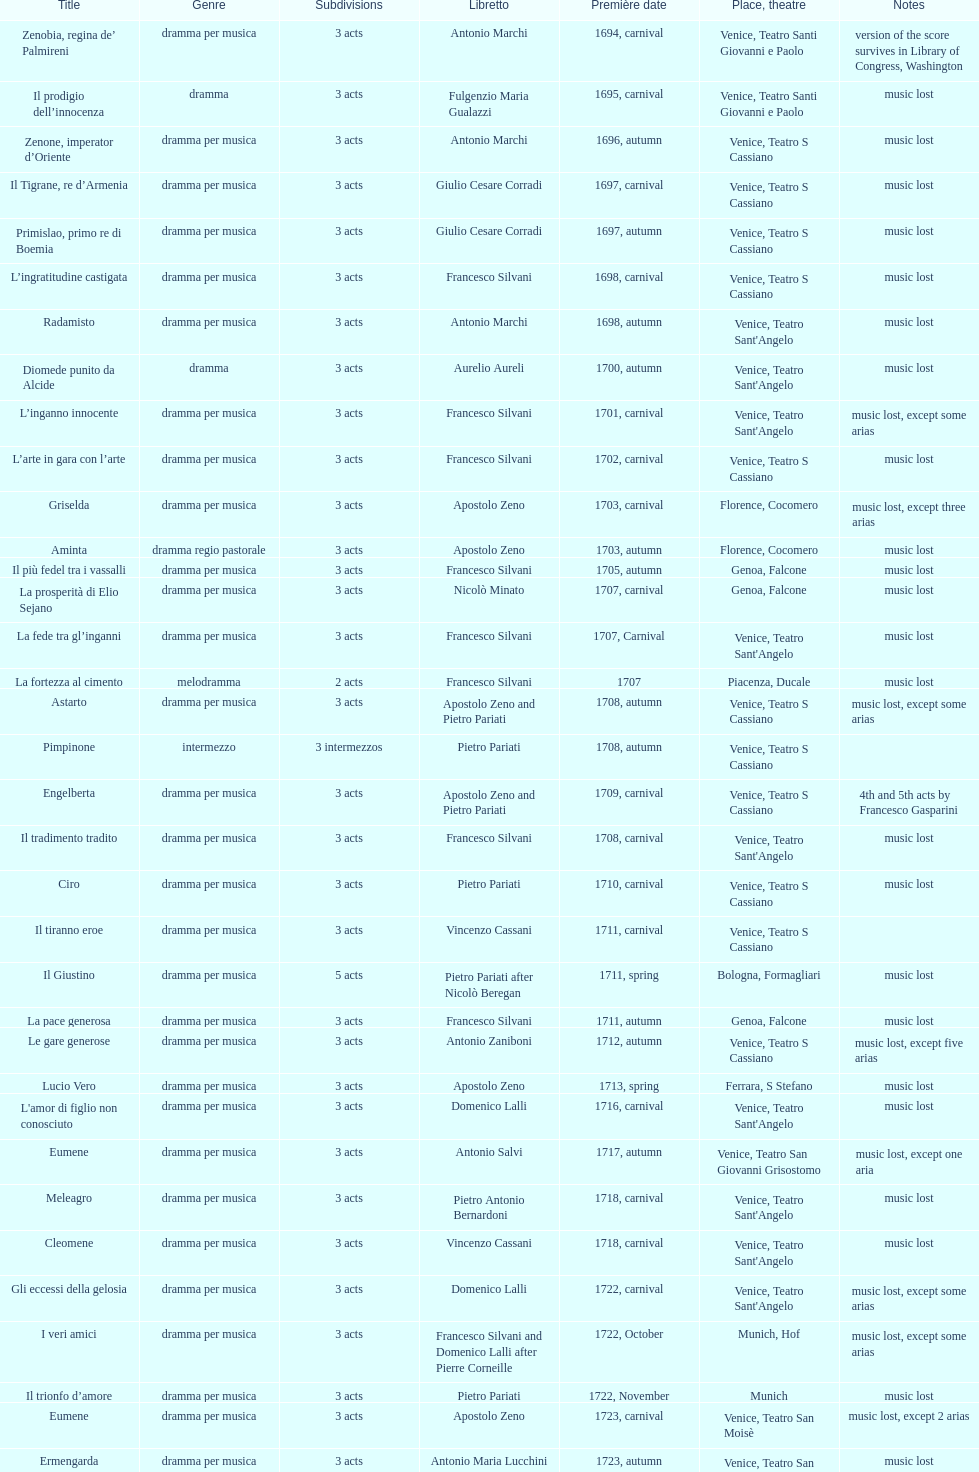How many operas on this list consist of 3 or more acts? 51. 